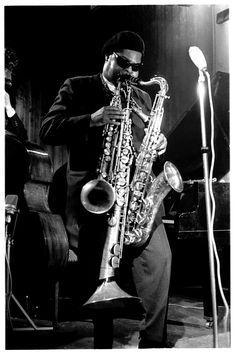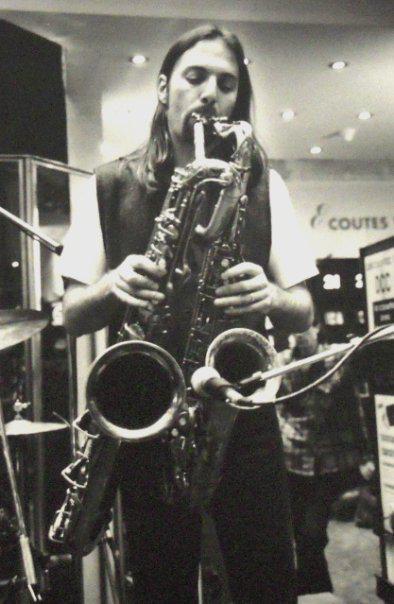The first image is the image on the left, the second image is the image on the right. For the images displayed, is the sentence "A musician is holding a guitar in the right image." factually correct? Answer yes or no. No. The first image is the image on the left, the second image is the image on the right. Examine the images to the left and right. Is the description "In one of the image there is a man playing a guitar in his lap." accurate? Answer yes or no. No. 